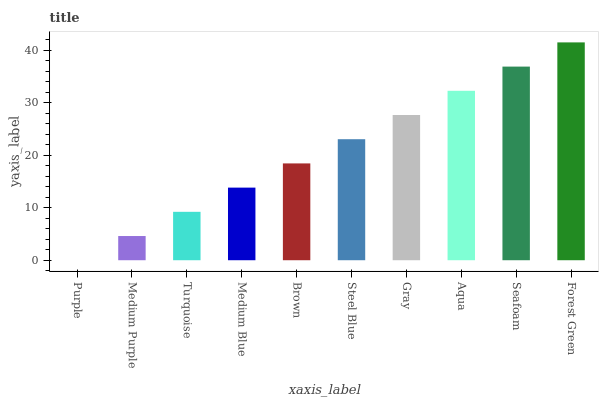Is Medium Purple the minimum?
Answer yes or no. No. Is Medium Purple the maximum?
Answer yes or no. No. Is Medium Purple greater than Purple?
Answer yes or no. Yes. Is Purple less than Medium Purple?
Answer yes or no. Yes. Is Purple greater than Medium Purple?
Answer yes or no. No. Is Medium Purple less than Purple?
Answer yes or no. No. Is Steel Blue the high median?
Answer yes or no. Yes. Is Brown the low median?
Answer yes or no. Yes. Is Brown the high median?
Answer yes or no. No. Is Turquoise the low median?
Answer yes or no. No. 